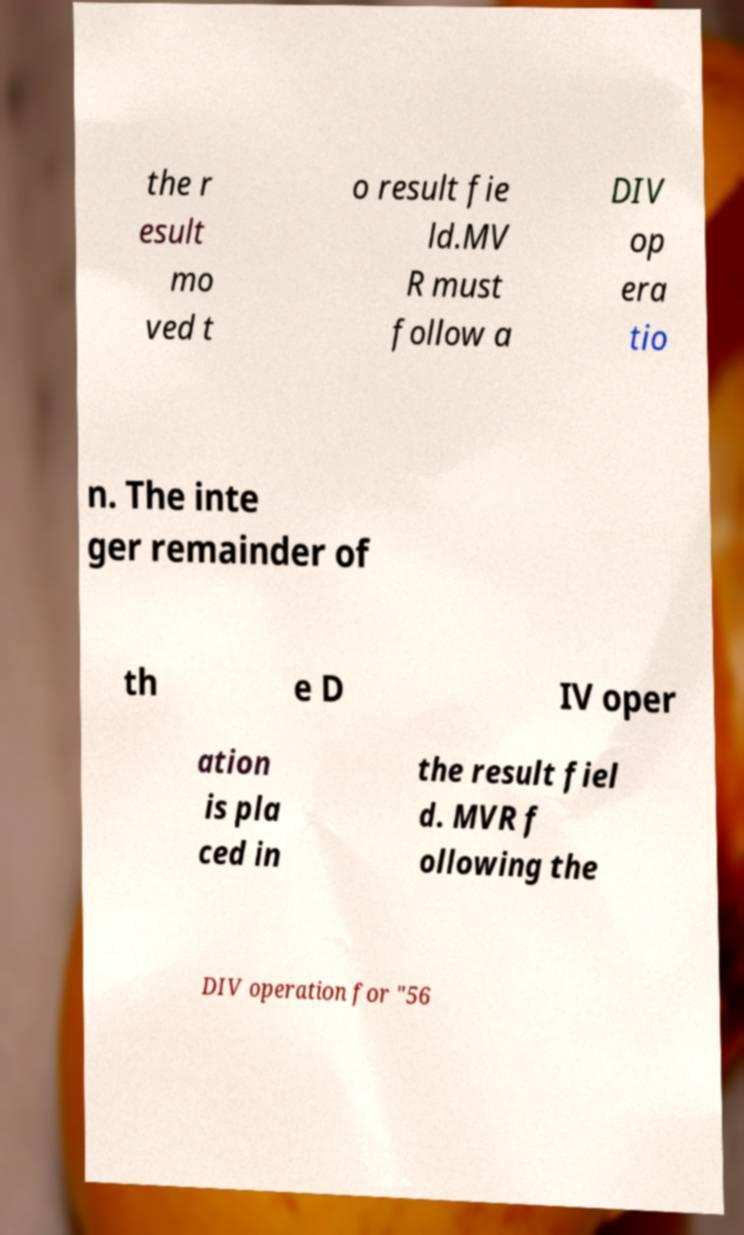Please read and relay the text visible in this image. What does it say? the r esult mo ved t o result fie ld.MV R must follow a DIV op era tio n. The inte ger remainder of th e D IV oper ation is pla ced in the result fiel d. MVR f ollowing the DIV operation for "56 